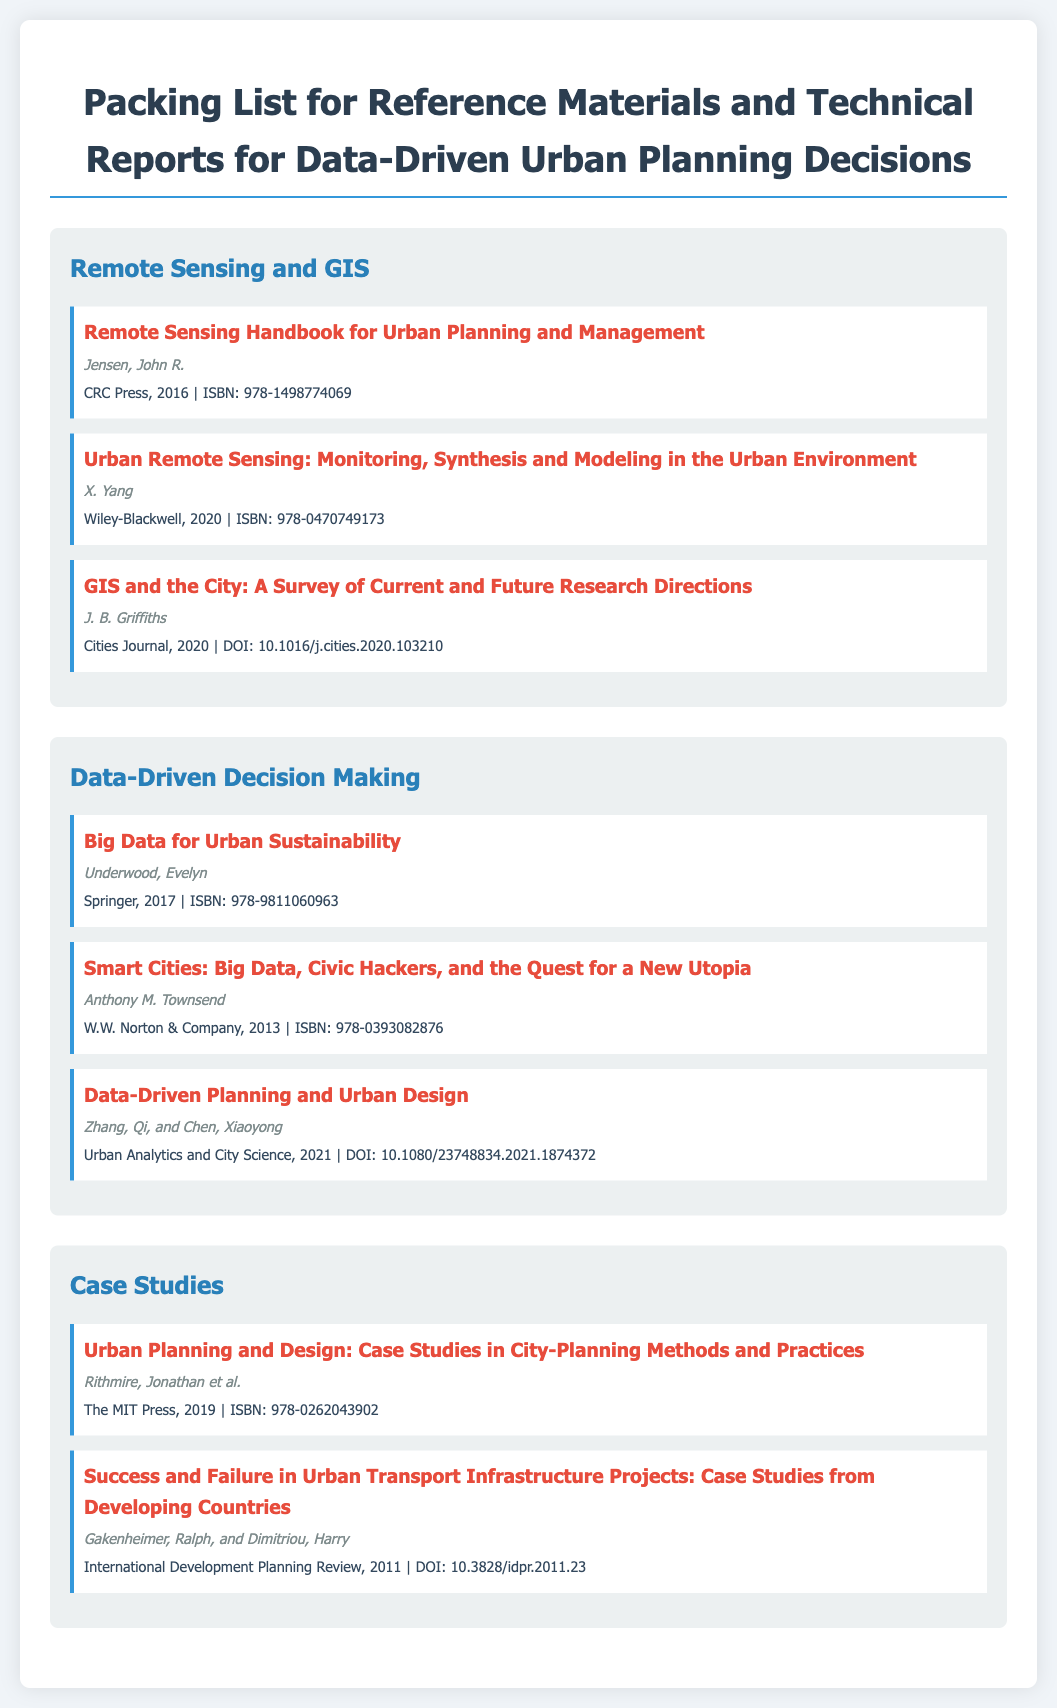What is the title of the handbook authored by John R. Jensen? The title of the handbook is mentioned in the Remote Sensing and GIS category.
Answer: Remote Sensing Handbook for Urban Planning and Management Who is the author of "Urban Remote Sensing"? The author's name is listed with the book title under the same category.
Answer: X. Yang What year was "Big Data for Urban Sustainability" published? The publication year is provided in the details of the book under the Data-Driven Decision Making category.
Answer: 2017 What is the ISBN of "Smart Cities: Big Data, Civic Hackers, and the Quest for a New Utopia"? The ISBN is included in the details for the book in the packing list.
Answer: 978-0393082876 How many materials are listed under the category "Case Studies"? The number of materials in a category can be counted directly from the list presented in the document.
Answer: 2 Which publisher released the "Remote Sensing Handbook for Urban Planning and Management"? The publisher information is specified in the details of the material under Remote Sensing and GIS.
Answer: CRC Press What is the DOI for "Data-Driven Planning and Urban Design"? The DOI is provided in the details of the material listed in the document.
Answer: 10.1080/23748834.2021.1874372 Which journal published the article by J. B. Griffiths? The journal name is mentioned in the details of the material under Remote Sensing and GIS.
Answer: Cities Journal Who authored the case study on urban transport infrastructure projects? The author's name can be found in the details associated with the listed material.
Answer: Gakenheimer, Ralph, and Dimitriou, Harry 